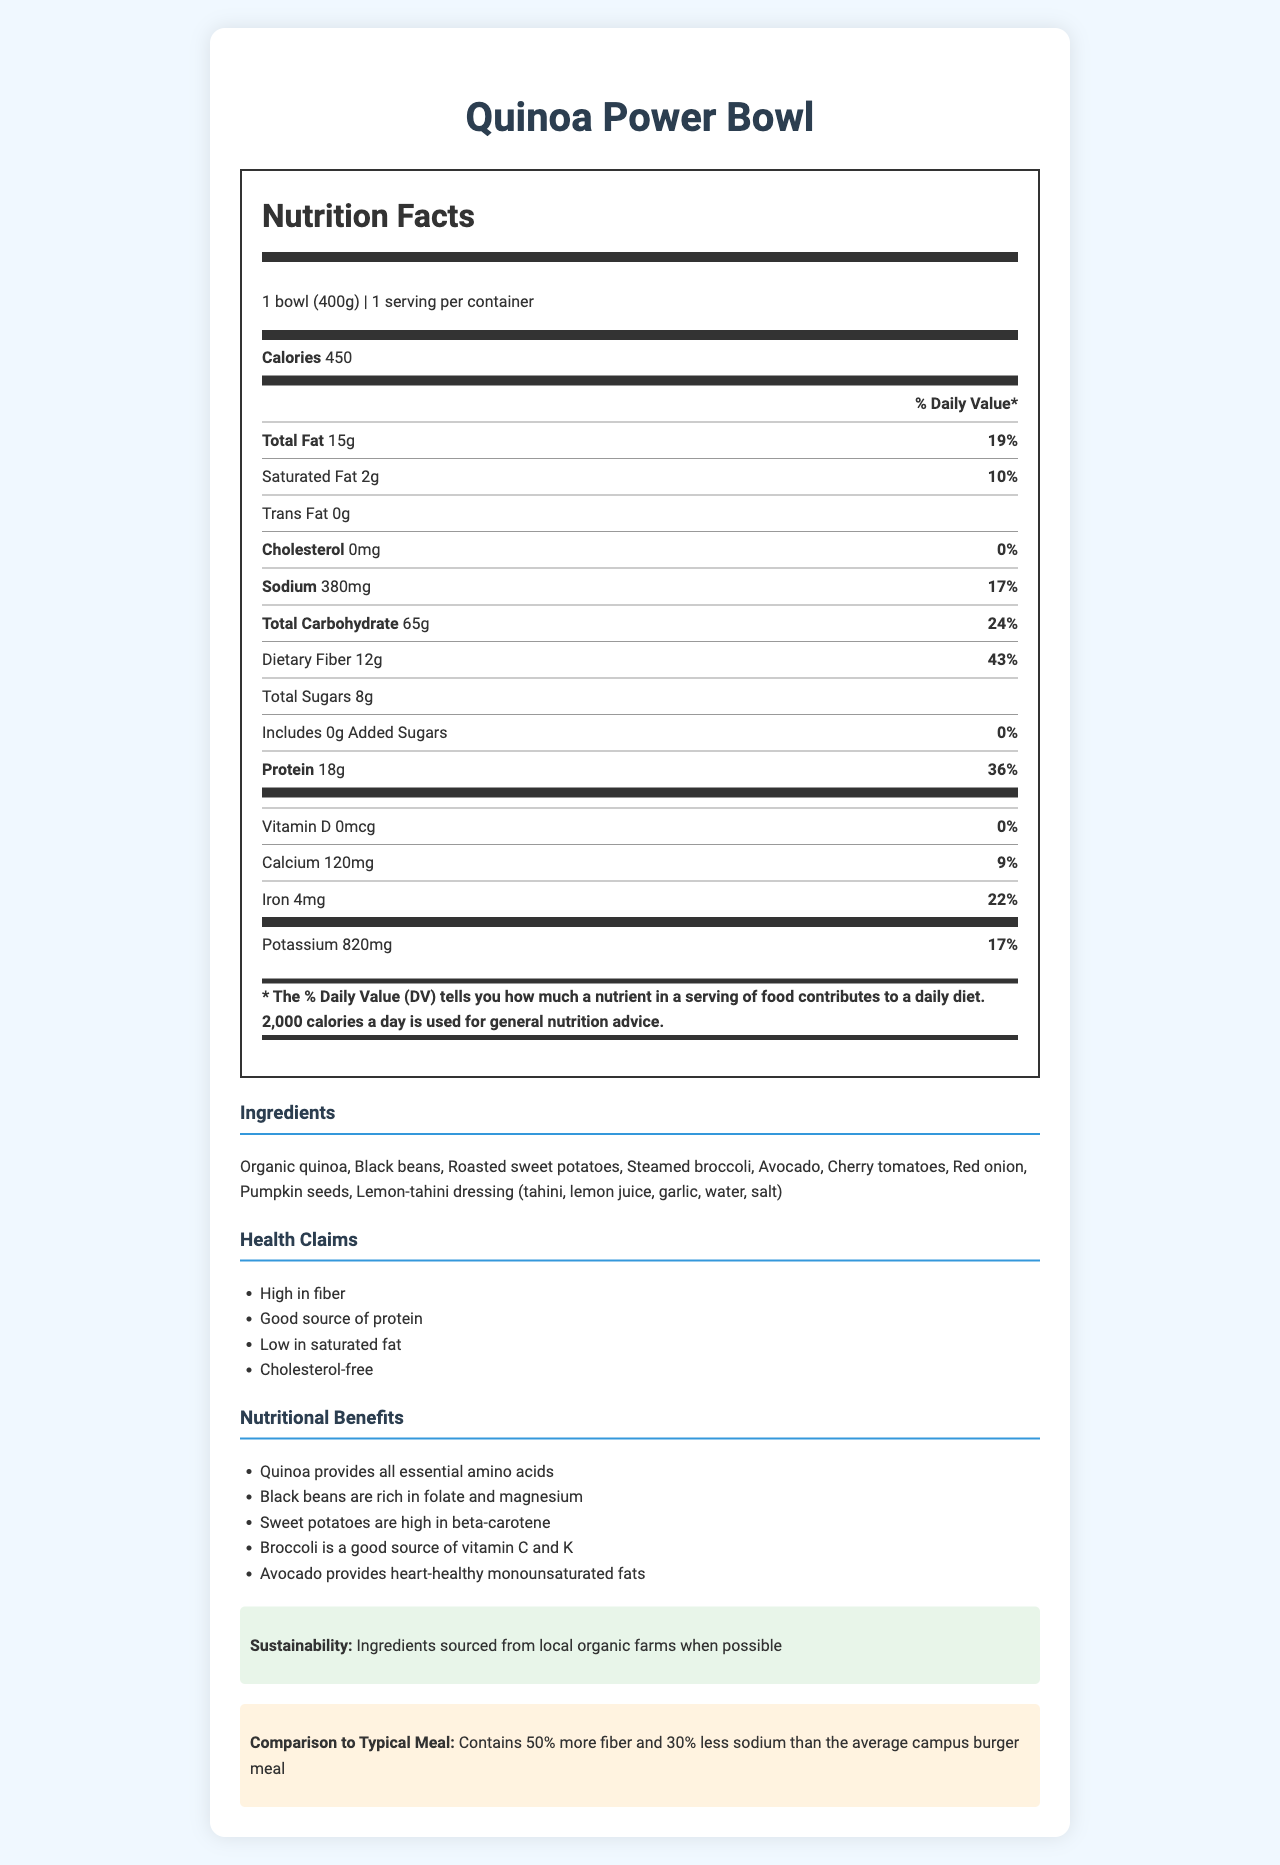What is the serving size for the Quinoa Power Bowl? The serving size is clearly mentioned as "1 bowl (400g)" at the top of the nutrition label.
Answer: 1 bowl (400g) How many calories are in one serving of the Quinoa Power Bowl? The calories per serving are listed prominently in the Nutrition Facts section at the top.
Answer: 450 calories What percentage of the Daily Value for dietary fiber does the Quinoa Power Bowl provide? The document states that the bowl contains 12g of dietary fiber which is 43% of the Daily Value.
Answer: 43% List three main ingredients in the Quinoa Power Bowl. These ingredients are listed at the top of the Ingredients section.
Answer: Organic quinoa, Black beans, Roasted sweet potatoes What is the main allergen in the Quinoa Power Bowl? The allergen is listed under the Allergens section.
Answer: Sesame How much sodium is in the Quinoa Power Bowl? The sodium content is listed under the Nutrition Facts section.
Answer: 380 mg Does the Quinoa Power Bowl contain any added sugars? (Yes/No) The Nutrition Facts section shows 0g of added sugars.
Answer: No Which of the following health claims are made about the Quinoa Power Bowl? A. High in cholesterol B. High in fiber C. High in added sugars The Health Claims section lists "High in fiber" as one of its claims, while it specifically states cholesterol-free and 0g added sugars.
Answer: B. High in fiber Which of the following nutritional benefits does the Quinoa Power Bowl offer due to black beans? A. High in vitamin D B. High in magnesium C. High in potassium According to the Nutritional Benefits section, black beans are rich in folate and magnesium.
Answer: B. High in magnesium What portion of the Daily Value for calcium does the Quinoa Power Bowl provide? A. 22% B. 9% C. 36% The Nutrition Facts section lists 9% daily value for calcium.
Answer: B. 9% Summarize the main nutritional benefits of the Quinoa Power Bowl. The Quinoa Power Bowl's main advantages include high dietary fiber, good protein content, low saturated fat and cholesterol-free components. Its ingredients offer various health benefits such as essential amino acids, minerals, and vitamins. Additionally, it is more nutritious than a typical campus burger meal.
Answer: The Quinoa Power Bowl is high in dietary fiber, a good source of protein, low in saturated fat, and cholesterol-free. It also provides essential amino acids, magnesium, beta-carotene, vitamins C and K, and heart-healthy monounsaturated fats. The ingredients are sourced from local organic farms when possible and the bowl contains 50% more fiber and 30% less sodium than the average campus burger meal. Where is the quinoa sourced from? The document mentions that ingredients are sourced from local organic farms when possible, but it does not specify the source of quinoa individually.
Answer: Not enough information 